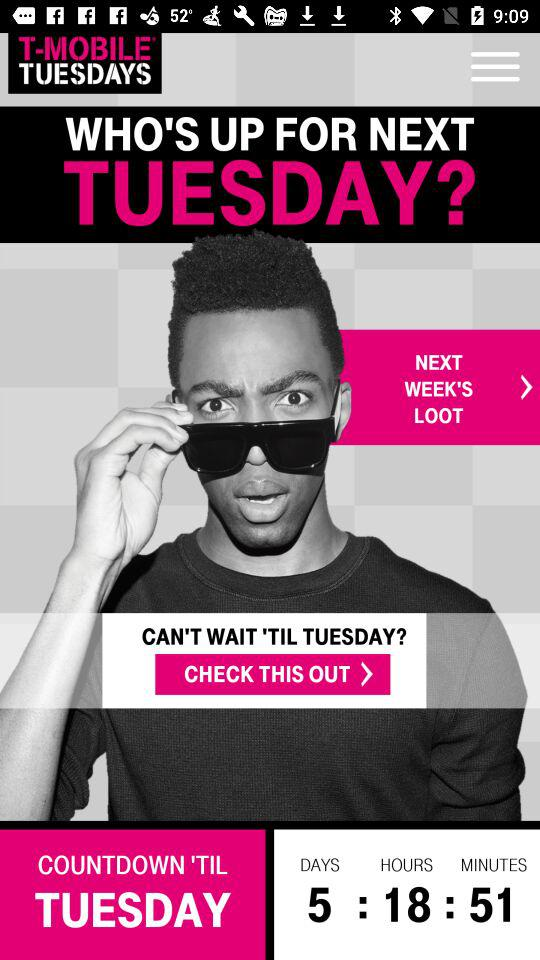How many more days until Tuesday?
Answer the question using a single word or phrase. 5 